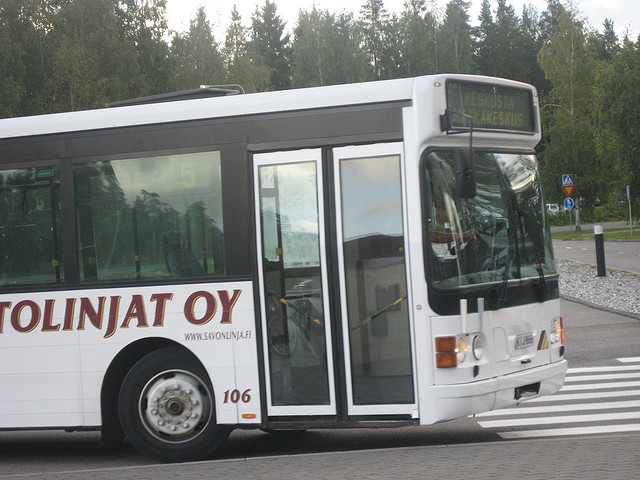Please extract the text content from this image. OY 106 TOLINJAT 